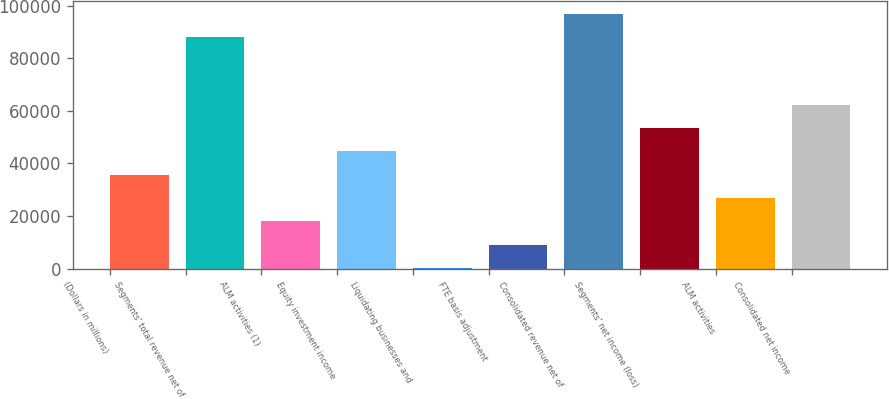<chart> <loc_0><loc_0><loc_500><loc_500><bar_chart><fcel>(Dollars in millions)<fcel>Segments' total revenue net of<fcel>ALM activities (1)<fcel>Equity investment income<fcel>Liquidating businesses and<fcel>FTE basis adjustment<fcel>Consolidated revenue net of<fcel>Segments' net income (loss)<fcel>ALM activities<fcel>Consolidated net income<nl><fcel>35735.8<fcel>87912<fcel>18000.4<fcel>44603.5<fcel>265<fcel>9132.7<fcel>96779.7<fcel>53471.2<fcel>26868.1<fcel>62338.9<nl></chart> 